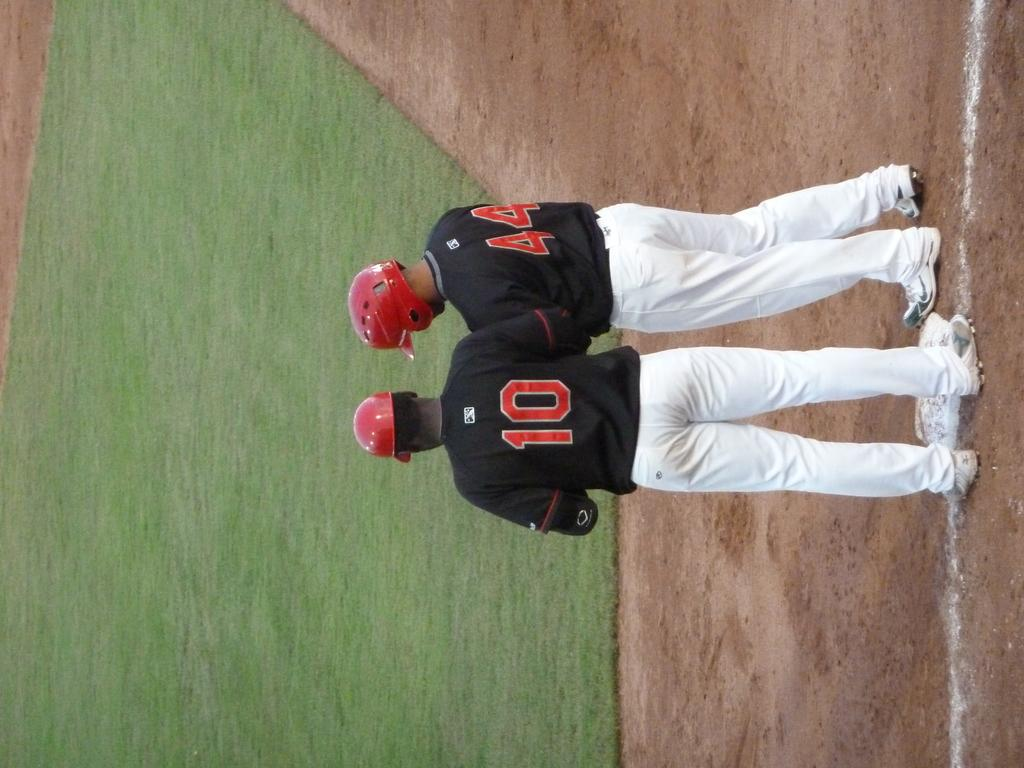Provide a one-sentence caption for the provided image. Two baseball players with numbers 10 and 44 standing at the field. 